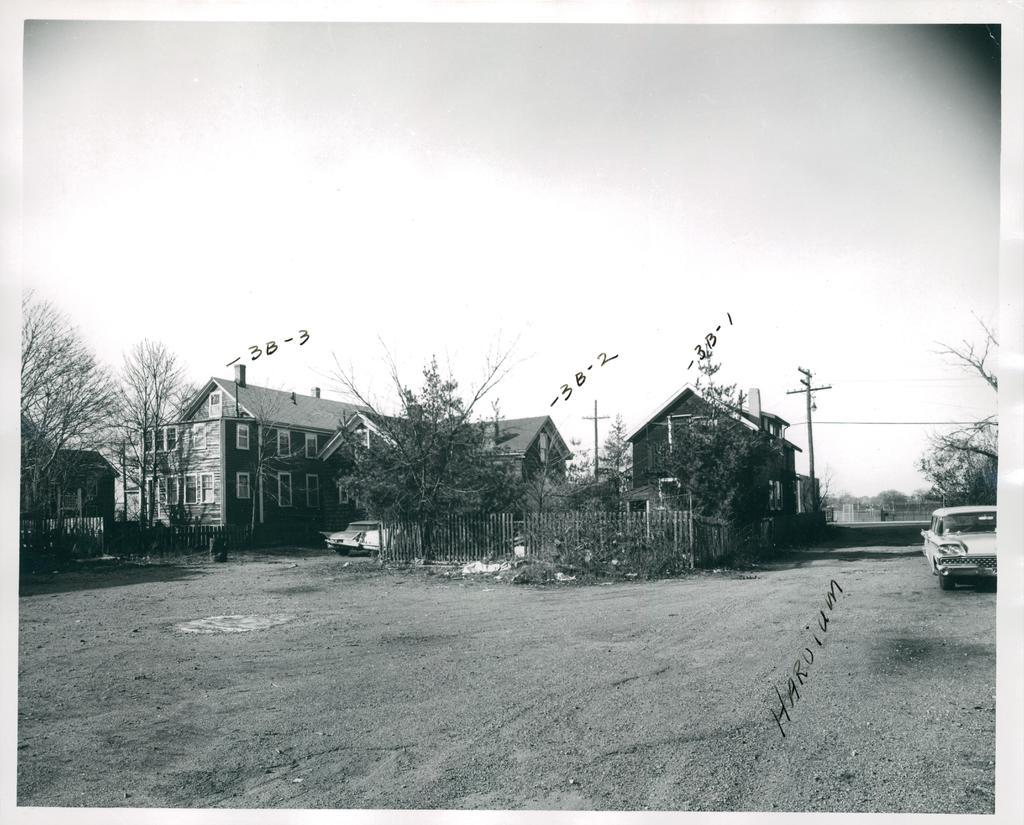What type of surface can be seen in the image? There is ground visible in the image. What type of barrier is present in the image? There is a fence in the image. What type of vegetation is present in the image? There are trees in the image. What type of structures are present in the image? There are buildings in the image. What type of vertical structures are present in the image? There are poles in the image. What type of written information is present in the image? There is text in the image. What type of transportation is present in the image? There is a vehicle in the image. What type of numerical information is present in the image? There are numbers in the image. What can be seen in the background of the image? The sky is visible in the background of the image. Can you tell me what type of doctor is present in the image? There is no doctor present in the image. What type of rod can be seen in the image? There is no rod present in the image. 